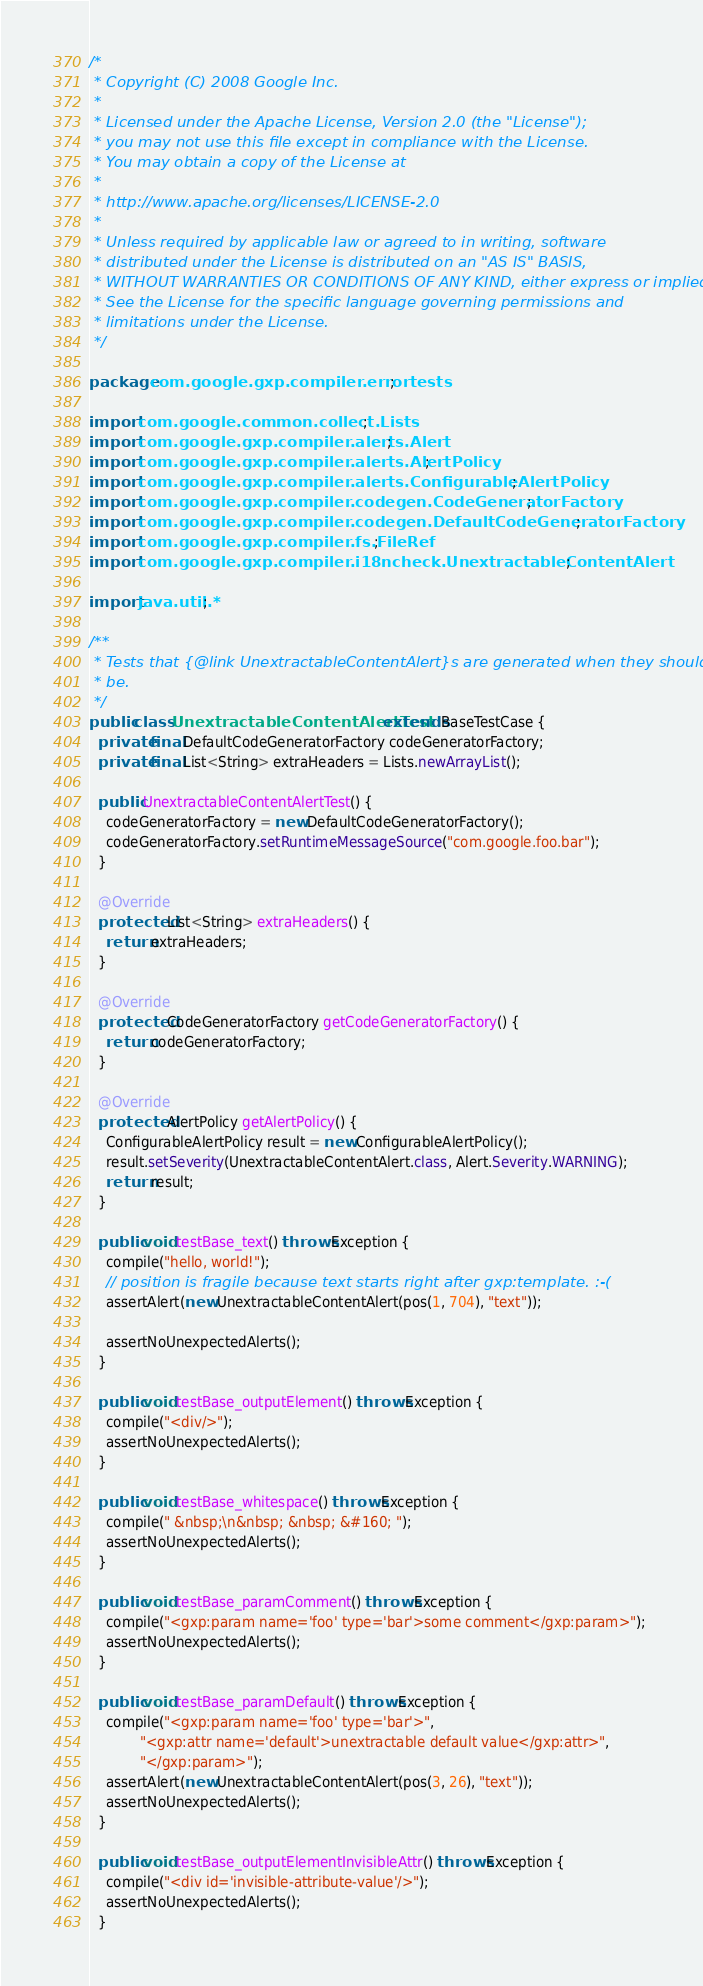<code> <loc_0><loc_0><loc_500><loc_500><_Java_>/*
 * Copyright (C) 2008 Google Inc.
 *
 * Licensed under the Apache License, Version 2.0 (the "License");
 * you may not use this file except in compliance with the License.
 * You may obtain a copy of the License at
 *
 * http://www.apache.org/licenses/LICENSE-2.0
 *
 * Unless required by applicable law or agreed to in writing, software
 * distributed under the License is distributed on an "AS IS" BASIS,
 * WITHOUT WARRANTIES OR CONDITIONS OF ANY KIND, either express or implied.
 * See the License for the specific language governing permissions and
 * limitations under the License.
 */

package com.google.gxp.compiler.errortests;

import com.google.common.collect.Lists;
import com.google.gxp.compiler.alerts.Alert;
import com.google.gxp.compiler.alerts.AlertPolicy;
import com.google.gxp.compiler.alerts.ConfigurableAlertPolicy;
import com.google.gxp.compiler.codegen.CodeGeneratorFactory;
import com.google.gxp.compiler.codegen.DefaultCodeGeneratorFactory;
import com.google.gxp.compiler.fs.FileRef;
import com.google.gxp.compiler.i18ncheck.UnextractableContentAlert;

import java.util.*;

/**
 * Tests that {@link UnextractableContentAlert}s are generated when they should
 * be.
 */
public class UnextractableContentAlertTest extends BaseTestCase {
  private final DefaultCodeGeneratorFactory codeGeneratorFactory;
  private final List<String> extraHeaders = Lists.newArrayList();

  public UnextractableContentAlertTest() {
    codeGeneratorFactory = new DefaultCodeGeneratorFactory();
    codeGeneratorFactory.setRuntimeMessageSource("com.google.foo.bar");
  }

  @Override
  protected List<String> extraHeaders() {
    return extraHeaders;
  }

  @Override
  protected CodeGeneratorFactory getCodeGeneratorFactory() {
    return codeGeneratorFactory;
  }

  @Override
  protected AlertPolicy getAlertPolicy() {
    ConfigurableAlertPolicy result = new ConfigurableAlertPolicy();
    result.setSeverity(UnextractableContentAlert.class, Alert.Severity.WARNING);
    return result;
  }

  public void testBase_text() throws Exception {
    compile("hello, world!");
    // position is fragile because text starts right after gxp:template. :-(
    assertAlert(new UnextractableContentAlert(pos(1, 704), "text"));

    assertNoUnexpectedAlerts();
  }

  public void testBase_outputElement() throws Exception {
    compile("<div/>");
    assertNoUnexpectedAlerts();
  }

  public void testBase_whitespace() throws Exception {
    compile(" &nbsp;\n&nbsp; &nbsp; &#160; ");
    assertNoUnexpectedAlerts();
  }

  public void testBase_paramComment() throws Exception {
    compile("<gxp:param name='foo' type='bar'>some comment</gxp:param>");
    assertNoUnexpectedAlerts();
  }

  public void testBase_paramDefault() throws Exception {
    compile("<gxp:param name='foo' type='bar'>",
            "<gxp:attr name='default'>unextractable default value</gxp:attr>",
            "</gxp:param>");
    assertAlert(new UnextractableContentAlert(pos(3, 26), "text"));
    assertNoUnexpectedAlerts();
  }

  public void testBase_outputElementInvisibleAttr() throws Exception {
    compile("<div id='invisible-attribute-value'/>");
    assertNoUnexpectedAlerts();
  }
</code> 